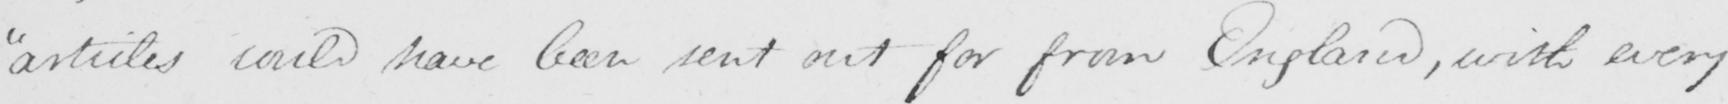What does this handwritten line say? articles could have been sent out for from England , with every 